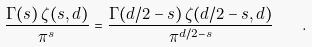Convert formula to latex. <formula><loc_0><loc_0><loc_500><loc_500>\frac { \Gamma ( s ) \, \zeta ( s , d ) } { \pi ^ { s } } = \frac { \Gamma ( d / 2 - s ) \, \zeta ( d / 2 - s , d ) } { \pi ^ { d / 2 - s } } \quad .</formula> 